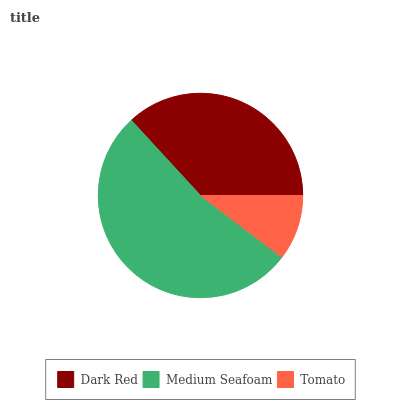Is Tomato the minimum?
Answer yes or no. Yes. Is Medium Seafoam the maximum?
Answer yes or no. Yes. Is Medium Seafoam the minimum?
Answer yes or no. No. Is Tomato the maximum?
Answer yes or no. No. Is Medium Seafoam greater than Tomato?
Answer yes or no. Yes. Is Tomato less than Medium Seafoam?
Answer yes or no. Yes. Is Tomato greater than Medium Seafoam?
Answer yes or no. No. Is Medium Seafoam less than Tomato?
Answer yes or no. No. Is Dark Red the high median?
Answer yes or no. Yes. Is Dark Red the low median?
Answer yes or no. Yes. Is Tomato the high median?
Answer yes or no. No. Is Medium Seafoam the low median?
Answer yes or no. No. 